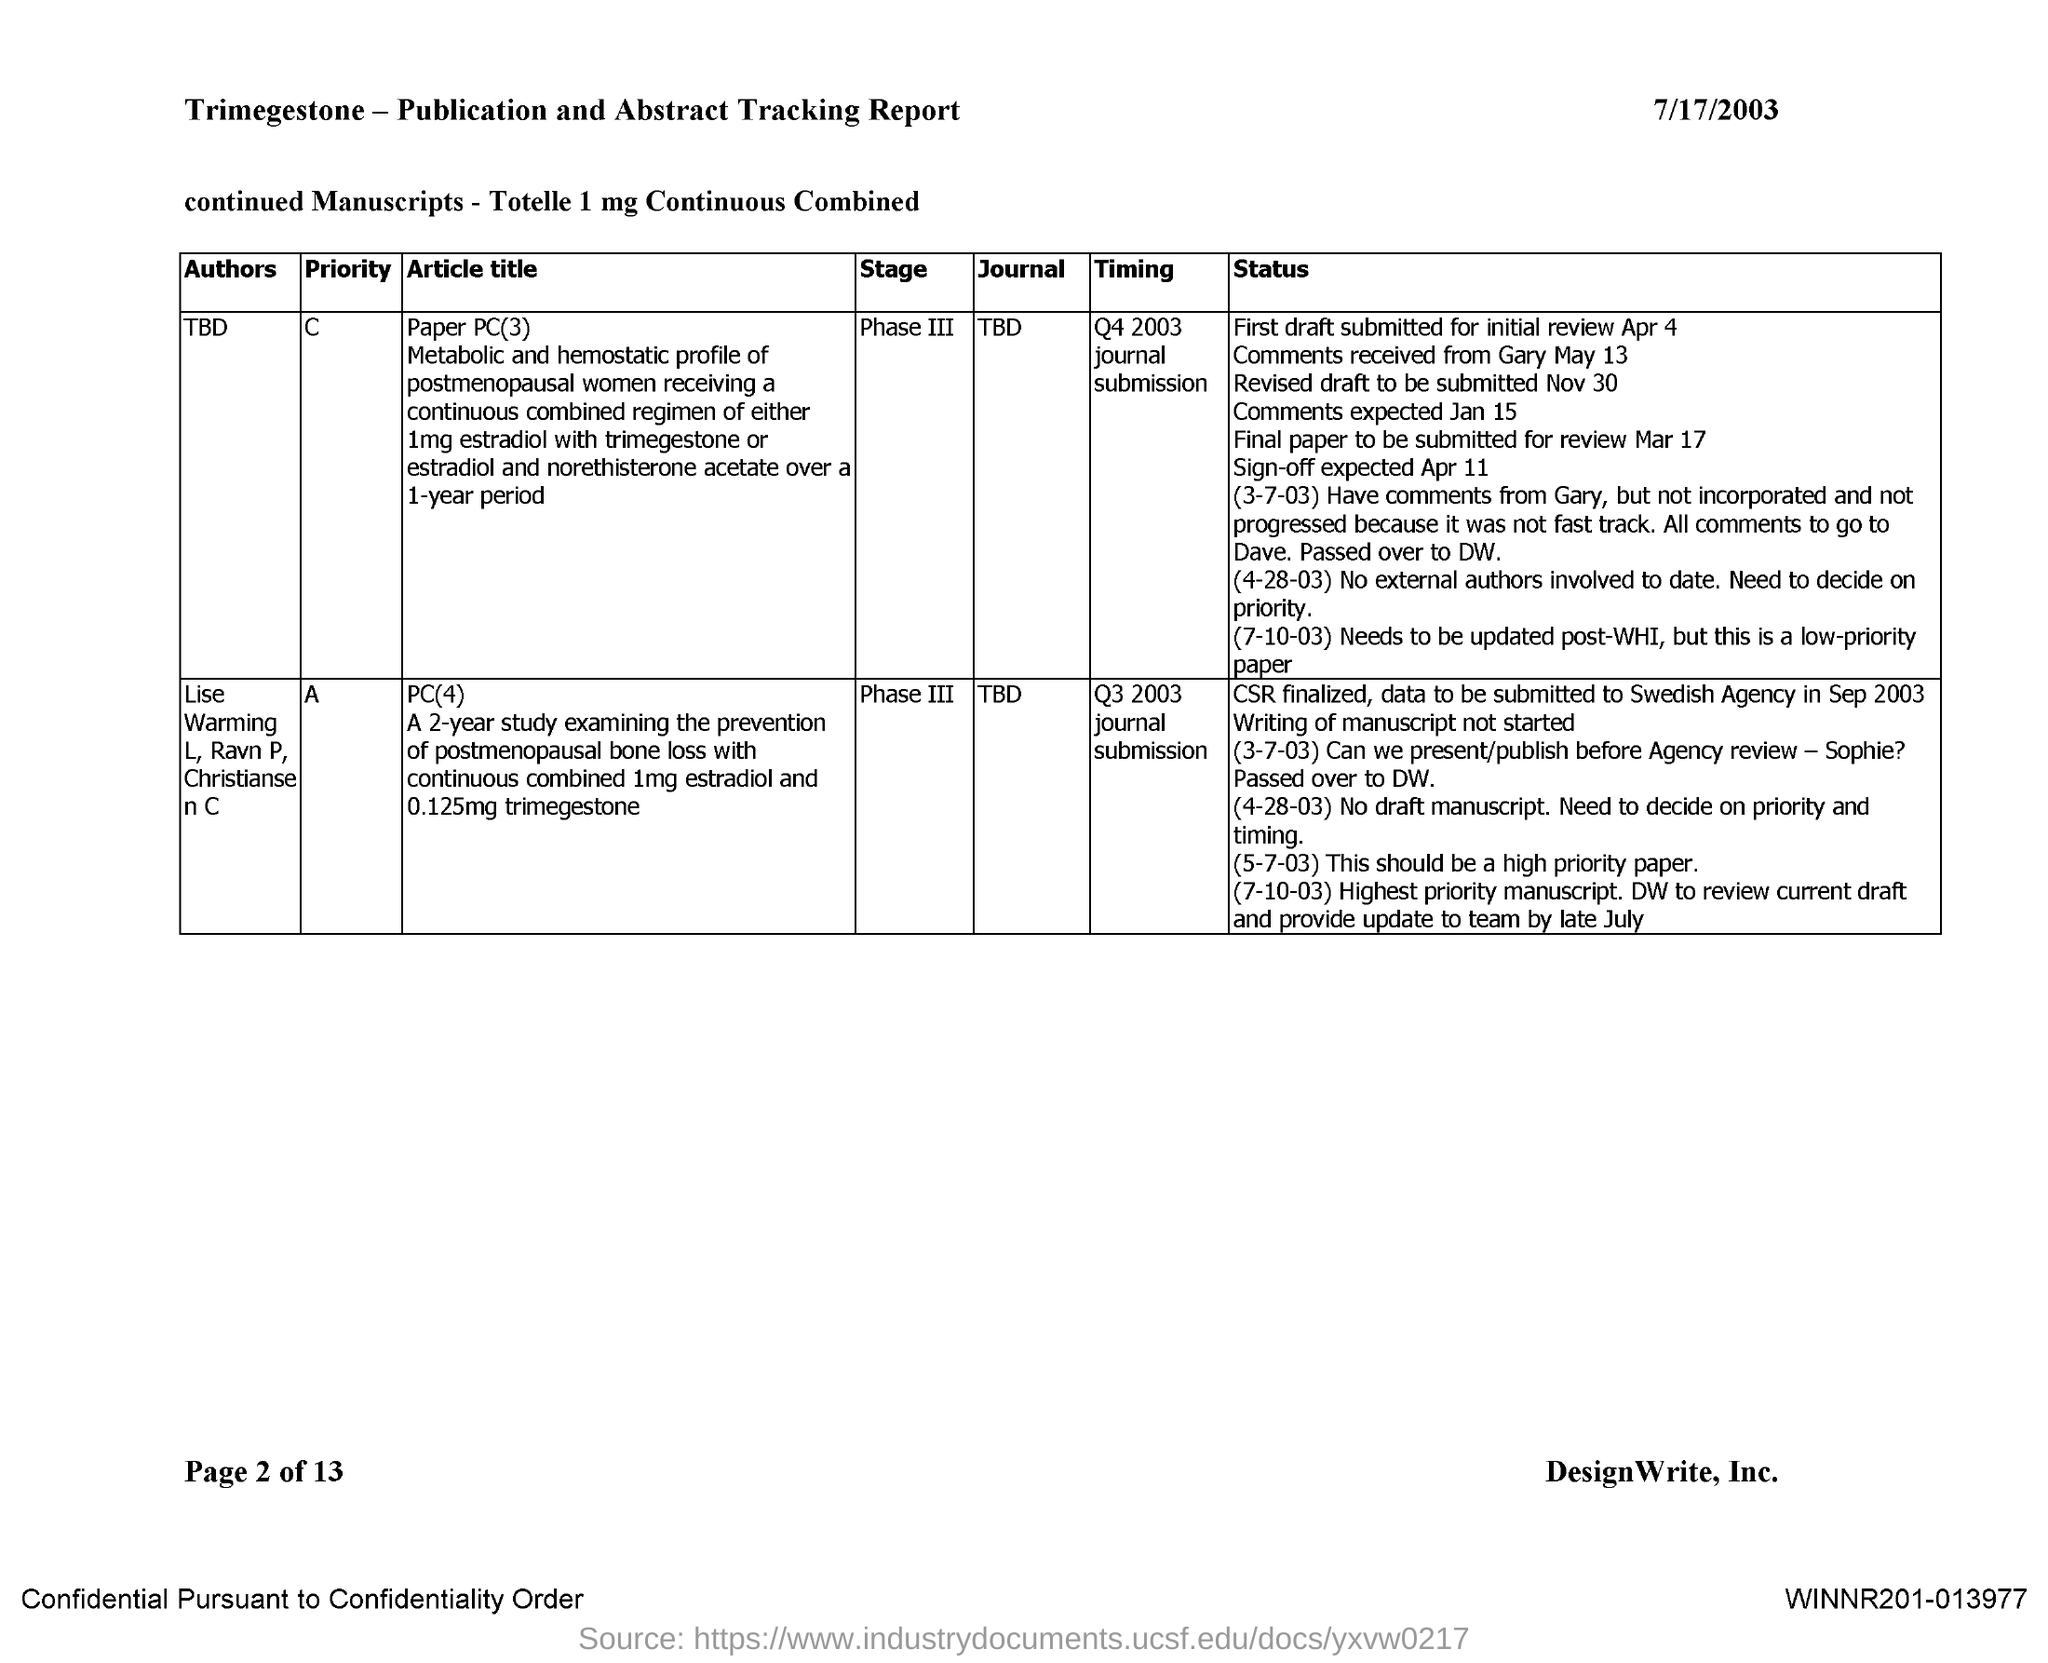What is the date mentioned in the document?
Offer a very short reply. 7/17/2003. What is the name of the journal with priority "A"?
Your response must be concise. TBD. What is the name of the journal with priority "C"?
Ensure brevity in your answer.  TBD. What is the name of the author of the journal with priority "C"?
Offer a very short reply. TBD. What is the name of the authors of the journal with priority "A"?
Provide a succinct answer. LIse Warming l, Ravn P, Christiansen C. What is the current stage of the journal with priority "C"?
Ensure brevity in your answer.  Phase III. What is the current stage of the journal with priority "A"?
Make the answer very short. Phase III. 